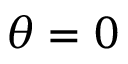<formula> <loc_0><loc_0><loc_500><loc_500>\theta = 0</formula> 